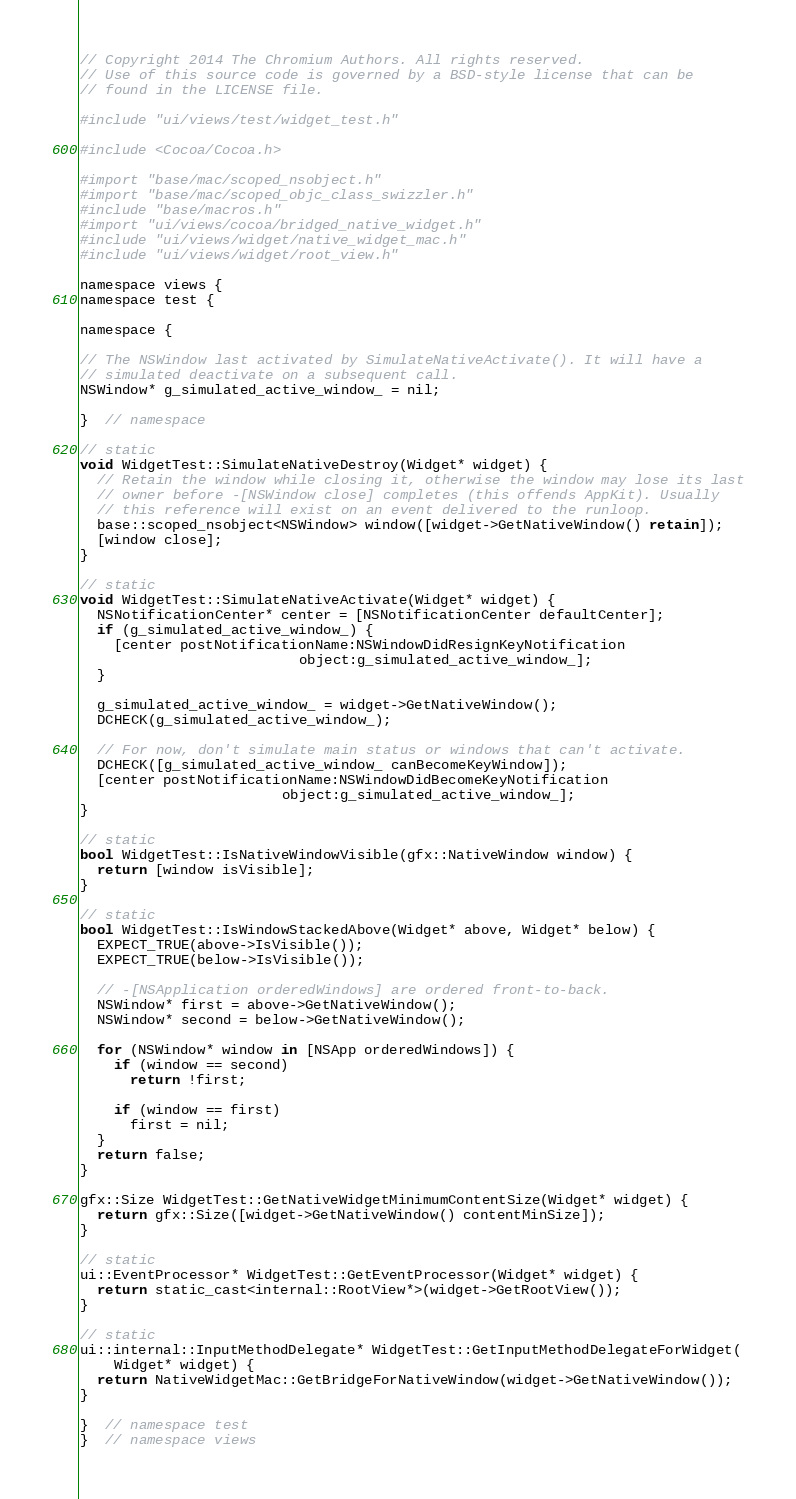Convert code to text. <code><loc_0><loc_0><loc_500><loc_500><_ObjectiveC_>// Copyright 2014 The Chromium Authors. All rights reserved.
// Use of this source code is governed by a BSD-style license that can be
// found in the LICENSE file.

#include "ui/views/test/widget_test.h"

#include <Cocoa/Cocoa.h>

#import "base/mac/scoped_nsobject.h"
#import "base/mac/scoped_objc_class_swizzler.h"
#include "base/macros.h"
#import "ui/views/cocoa/bridged_native_widget.h"
#include "ui/views/widget/native_widget_mac.h"
#include "ui/views/widget/root_view.h"

namespace views {
namespace test {

namespace {

// The NSWindow last activated by SimulateNativeActivate(). It will have a
// simulated deactivate on a subsequent call.
NSWindow* g_simulated_active_window_ = nil;

}  // namespace

// static
void WidgetTest::SimulateNativeDestroy(Widget* widget) {
  // Retain the window while closing it, otherwise the window may lose its last
  // owner before -[NSWindow close] completes (this offends AppKit). Usually
  // this reference will exist on an event delivered to the runloop.
  base::scoped_nsobject<NSWindow> window([widget->GetNativeWindow() retain]);
  [window close];
}

// static
void WidgetTest::SimulateNativeActivate(Widget* widget) {
  NSNotificationCenter* center = [NSNotificationCenter defaultCenter];
  if (g_simulated_active_window_) {
    [center postNotificationName:NSWindowDidResignKeyNotification
                          object:g_simulated_active_window_];
  }

  g_simulated_active_window_ = widget->GetNativeWindow();
  DCHECK(g_simulated_active_window_);

  // For now, don't simulate main status or windows that can't activate.
  DCHECK([g_simulated_active_window_ canBecomeKeyWindow]);
  [center postNotificationName:NSWindowDidBecomeKeyNotification
                        object:g_simulated_active_window_];
}

// static
bool WidgetTest::IsNativeWindowVisible(gfx::NativeWindow window) {
  return [window isVisible];
}

// static
bool WidgetTest::IsWindowStackedAbove(Widget* above, Widget* below) {
  EXPECT_TRUE(above->IsVisible());
  EXPECT_TRUE(below->IsVisible());

  // -[NSApplication orderedWindows] are ordered front-to-back.
  NSWindow* first = above->GetNativeWindow();
  NSWindow* second = below->GetNativeWindow();

  for (NSWindow* window in [NSApp orderedWindows]) {
    if (window == second)
      return !first;

    if (window == first)
      first = nil;
  }
  return false;
}

gfx::Size WidgetTest::GetNativeWidgetMinimumContentSize(Widget* widget) {
  return gfx::Size([widget->GetNativeWindow() contentMinSize]);
}

// static
ui::EventProcessor* WidgetTest::GetEventProcessor(Widget* widget) {
  return static_cast<internal::RootView*>(widget->GetRootView());
}

// static
ui::internal::InputMethodDelegate* WidgetTest::GetInputMethodDelegateForWidget(
    Widget* widget) {
  return NativeWidgetMac::GetBridgeForNativeWindow(widget->GetNativeWindow());
}

}  // namespace test
}  // namespace views
</code> 